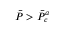Convert formula to latex. <formula><loc_0><loc_0><loc_500><loc_500>\ B a r { P } > \ B a r { P } _ { c } ^ { a }</formula> 